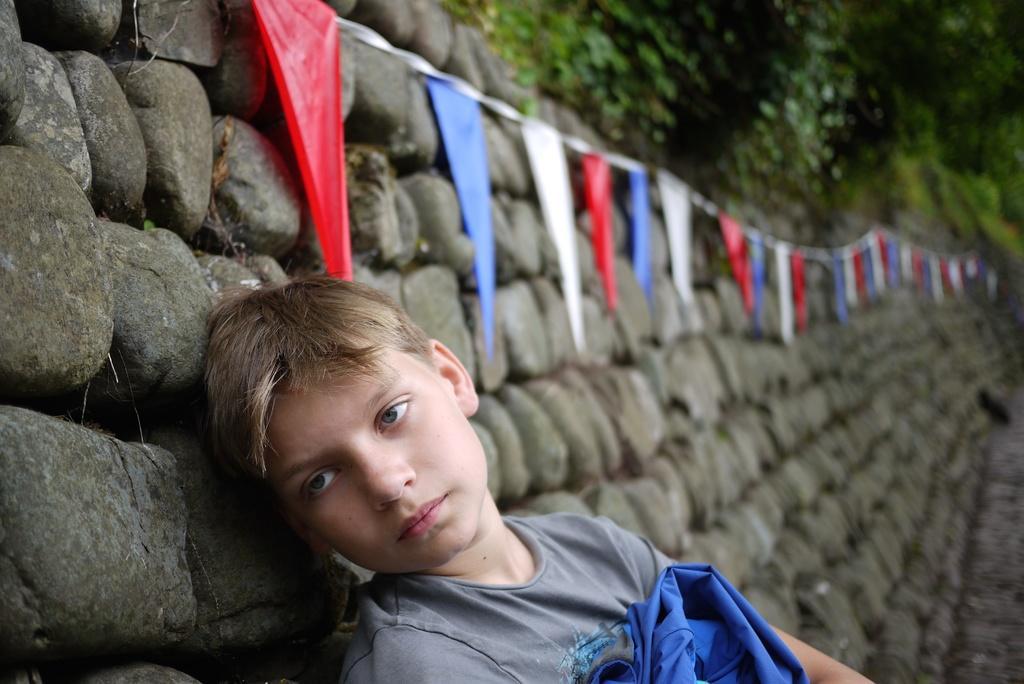In one or two sentences, can you explain what this image depicts? In the image there is a boy with a grey t-shirt. Behind him there is a stone wall with a decorative flags. At the top right of the image there are trees. 